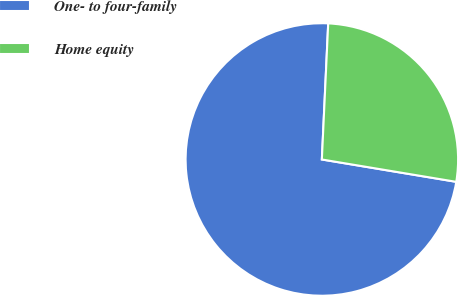Convert chart. <chart><loc_0><loc_0><loc_500><loc_500><pie_chart><fcel>One- to four-family<fcel>Home equity<nl><fcel>73.12%<fcel>26.88%<nl></chart> 